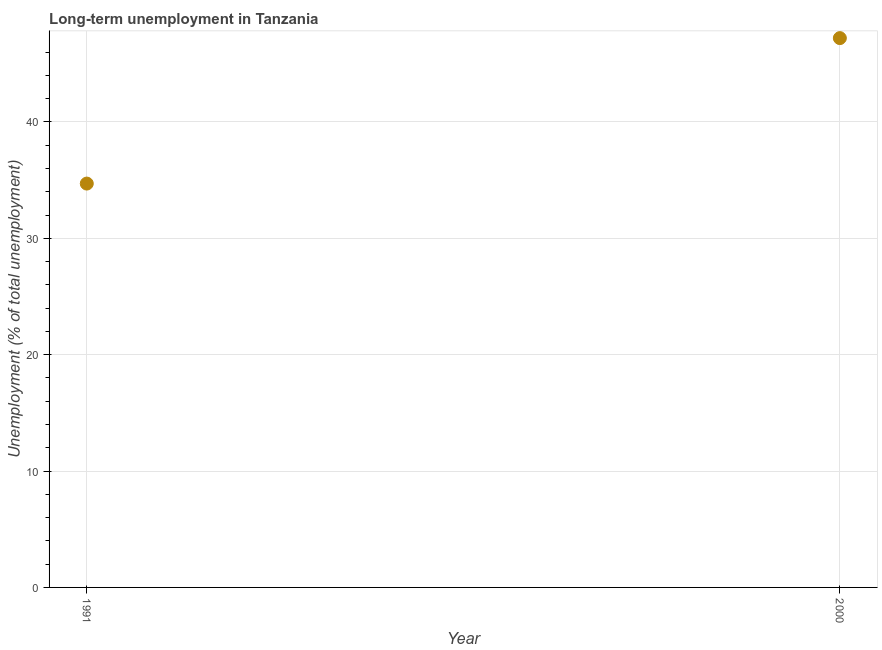What is the long-term unemployment in 2000?
Offer a very short reply. 47.2. Across all years, what is the maximum long-term unemployment?
Provide a succinct answer. 47.2. Across all years, what is the minimum long-term unemployment?
Provide a succinct answer. 34.7. In which year was the long-term unemployment maximum?
Keep it short and to the point. 2000. What is the sum of the long-term unemployment?
Provide a succinct answer. 81.9. What is the difference between the long-term unemployment in 1991 and 2000?
Keep it short and to the point. -12.5. What is the average long-term unemployment per year?
Keep it short and to the point. 40.95. What is the median long-term unemployment?
Offer a very short reply. 40.95. Do a majority of the years between 1991 and 2000 (inclusive) have long-term unemployment greater than 44 %?
Provide a short and direct response. No. What is the ratio of the long-term unemployment in 1991 to that in 2000?
Your answer should be very brief. 0.74. Is the long-term unemployment in 1991 less than that in 2000?
Your answer should be compact. Yes. In how many years, is the long-term unemployment greater than the average long-term unemployment taken over all years?
Your answer should be compact. 1. How many dotlines are there?
Your response must be concise. 1. How many years are there in the graph?
Provide a short and direct response. 2. Are the values on the major ticks of Y-axis written in scientific E-notation?
Your response must be concise. No. Does the graph contain grids?
Make the answer very short. Yes. What is the title of the graph?
Your answer should be very brief. Long-term unemployment in Tanzania. What is the label or title of the Y-axis?
Your answer should be very brief. Unemployment (% of total unemployment). What is the Unemployment (% of total unemployment) in 1991?
Your answer should be compact. 34.7. What is the Unemployment (% of total unemployment) in 2000?
Your answer should be very brief. 47.2. What is the difference between the Unemployment (% of total unemployment) in 1991 and 2000?
Provide a short and direct response. -12.5. What is the ratio of the Unemployment (% of total unemployment) in 1991 to that in 2000?
Your answer should be compact. 0.73. 